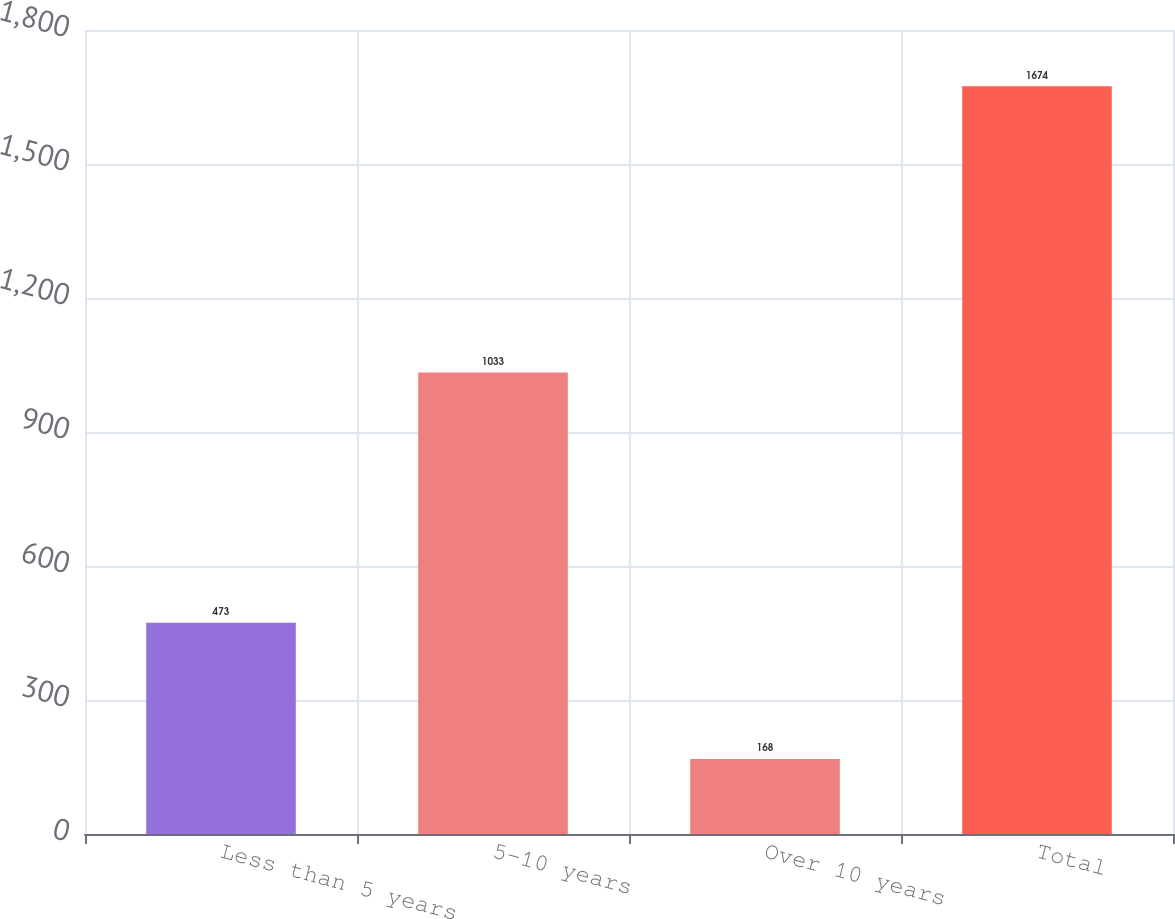Convert chart to OTSL. <chart><loc_0><loc_0><loc_500><loc_500><bar_chart><fcel>Less than 5 years<fcel>5-10 years<fcel>Over 10 years<fcel>Total<nl><fcel>473<fcel>1033<fcel>168<fcel>1674<nl></chart> 